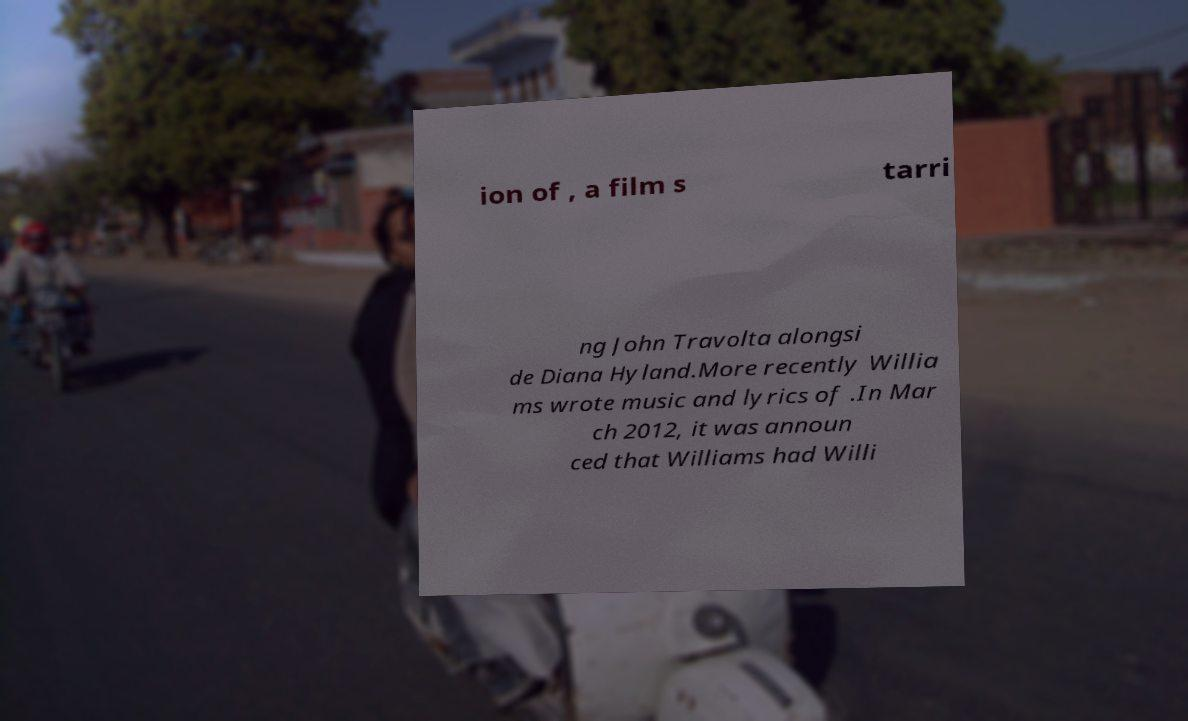There's text embedded in this image that I need extracted. Can you transcribe it verbatim? ion of , a film s tarri ng John Travolta alongsi de Diana Hyland.More recently Willia ms wrote music and lyrics of .In Mar ch 2012, it was announ ced that Williams had Willi 